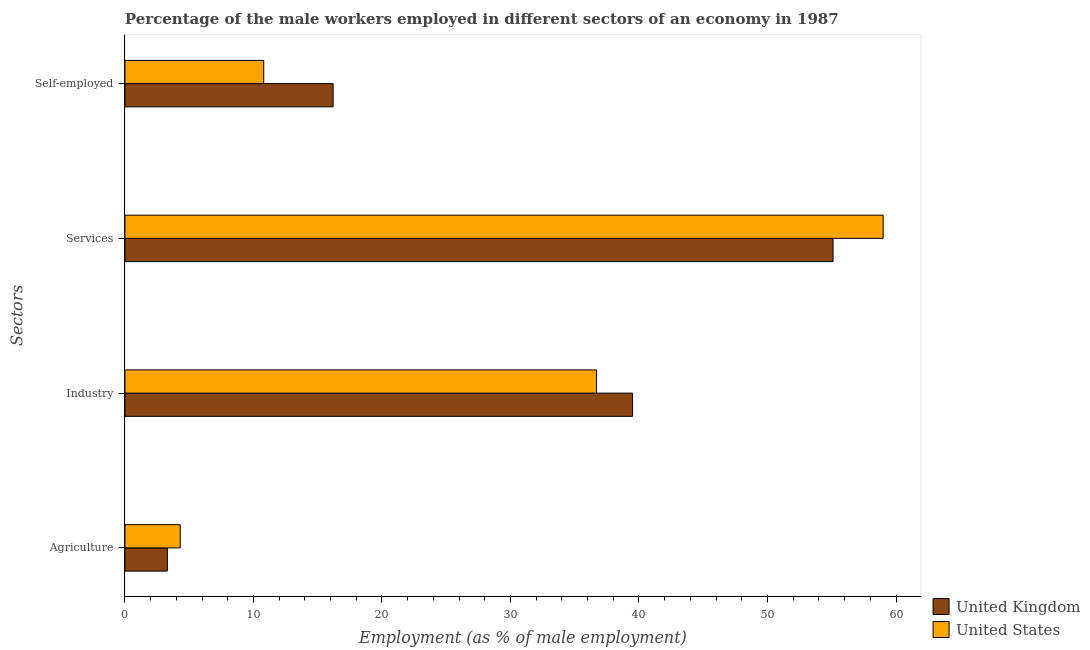Are the number of bars per tick equal to the number of legend labels?
Provide a succinct answer. Yes. What is the label of the 1st group of bars from the top?
Keep it short and to the point. Self-employed. What is the percentage of self employed male workers in United States?
Your response must be concise. 10.8. Across all countries, what is the maximum percentage of male workers in agriculture?
Offer a terse response. 4.3. Across all countries, what is the minimum percentage of male workers in industry?
Provide a short and direct response. 36.7. In which country was the percentage of self employed male workers minimum?
Keep it short and to the point. United States. What is the total percentage of male workers in agriculture in the graph?
Offer a very short reply. 7.6. What is the difference between the percentage of male workers in industry in United States and that in United Kingdom?
Make the answer very short. -2.8. What is the difference between the percentage of self employed male workers in United Kingdom and the percentage of male workers in services in United States?
Offer a very short reply. -42.8. What is the average percentage of male workers in services per country?
Provide a succinct answer. 57.05. What is the difference between the percentage of male workers in industry and percentage of self employed male workers in United Kingdom?
Offer a very short reply. 23.3. In how many countries, is the percentage of male workers in industry greater than 14 %?
Your response must be concise. 2. What is the ratio of the percentage of male workers in services in United Kingdom to that in United States?
Keep it short and to the point. 0.93. Is the percentage of self employed male workers in United Kingdom less than that in United States?
Your answer should be compact. No. Is the difference between the percentage of male workers in industry in United Kingdom and United States greater than the difference between the percentage of male workers in agriculture in United Kingdom and United States?
Provide a short and direct response. Yes. What is the difference between the highest and the second highest percentage of male workers in services?
Ensure brevity in your answer.  3.9. What is the difference between the highest and the lowest percentage of male workers in services?
Provide a succinct answer. 3.9. In how many countries, is the percentage of male workers in services greater than the average percentage of male workers in services taken over all countries?
Make the answer very short. 1. What does the 2nd bar from the top in Services represents?
Your response must be concise. United Kingdom. Is it the case that in every country, the sum of the percentage of male workers in agriculture and percentage of male workers in industry is greater than the percentage of male workers in services?
Your answer should be compact. No. How many bars are there?
Your response must be concise. 8. Are all the bars in the graph horizontal?
Your answer should be very brief. Yes. Where does the legend appear in the graph?
Offer a very short reply. Bottom right. How many legend labels are there?
Your response must be concise. 2. How are the legend labels stacked?
Provide a succinct answer. Vertical. What is the title of the graph?
Your response must be concise. Percentage of the male workers employed in different sectors of an economy in 1987. What is the label or title of the X-axis?
Give a very brief answer. Employment (as % of male employment). What is the label or title of the Y-axis?
Your answer should be very brief. Sectors. What is the Employment (as % of male employment) of United Kingdom in Agriculture?
Provide a short and direct response. 3.3. What is the Employment (as % of male employment) of United States in Agriculture?
Provide a succinct answer. 4.3. What is the Employment (as % of male employment) in United Kingdom in Industry?
Provide a short and direct response. 39.5. What is the Employment (as % of male employment) of United States in Industry?
Provide a succinct answer. 36.7. What is the Employment (as % of male employment) in United Kingdom in Services?
Provide a succinct answer. 55.1. What is the Employment (as % of male employment) in United States in Services?
Provide a short and direct response. 59. What is the Employment (as % of male employment) in United Kingdom in Self-employed?
Provide a succinct answer. 16.2. What is the Employment (as % of male employment) in United States in Self-employed?
Your response must be concise. 10.8. Across all Sectors, what is the maximum Employment (as % of male employment) of United Kingdom?
Your answer should be compact. 55.1. Across all Sectors, what is the minimum Employment (as % of male employment) of United Kingdom?
Keep it short and to the point. 3.3. Across all Sectors, what is the minimum Employment (as % of male employment) in United States?
Keep it short and to the point. 4.3. What is the total Employment (as % of male employment) in United Kingdom in the graph?
Provide a succinct answer. 114.1. What is the total Employment (as % of male employment) in United States in the graph?
Give a very brief answer. 110.8. What is the difference between the Employment (as % of male employment) of United Kingdom in Agriculture and that in Industry?
Provide a succinct answer. -36.2. What is the difference between the Employment (as % of male employment) in United States in Agriculture and that in Industry?
Your response must be concise. -32.4. What is the difference between the Employment (as % of male employment) in United Kingdom in Agriculture and that in Services?
Provide a short and direct response. -51.8. What is the difference between the Employment (as % of male employment) in United States in Agriculture and that in Services?
Give a very brief answer. -54.7. What is the difference between the Employment (as % of male employment) in United Kingdom in Industry and that in Services?
Provide a short and direct response. -15.6. What is the difference between the Employment (as % of male employment) in United States in Industry and that in Services?
Your response must be concise. -22.3. What is the difference between the Employment (as % of male employment) in United Kingdom in Industry and that in Self-employed?
Make the answer very short. 23.3. What is the difference between the Employment (as % of male employment) in United States in Industry and that in Self-employed?
Offer a terse response. 25.9. What is the difference between the Employment (as % of male employment) in United Kingdom in Services and that in Self-employed?
Your answer should be very brief. 38.9. What is the difference between the Employment (as % of male employment) in United States in Services and that in Self-employed?
Your response must be concise. 48.2. What is the difference between the Employment (as % of male employment) of United Kingdom in Agriculture and the Employment (as % of male employment) of United States in Industry?
Keep it short and to the point. -33.4. What is the difference between the Employment (as % of male employment) in United Kingdom in Agriculture and the Employment (as % of male employment) in United States in Services?
Your response must be concise. -55.7. What is the difference between the Employment (as % of male employment) in United Kingdom in Agriculture and the Employment (as % of male employment) in United States in Self-employed?
Provide a succinct answer. -7.5. What is the difference between the Employment (as % of male employment) in United Kingdom in Industry and the Employment (as % of male employment) in United States in Services?
Ensure brevity in your answer.  -19.5. What is the difference between the Employment (as % of male employment) in United Kingdom in Industry and the Employment (as % of male employment) in United States in Self-employed?
Your answer should be compact. 28.7. What is the difference between the Employment (as % of male employment) of United Kingdom in Services and the Employment (as % of male employment) of United States in Self-employed?
Give a very brief answer. 44.3. What is the average Employment (as % of male employment) of United Kingdom per Sectors?
Keep it short and to the point. 28.52. What is the average Employment (as % of male employment) in United States per Sectors?
Offer a very short reply. 27.7. What is the ratio of the Employment (as % of male employment) in United Kingdom in Agriculture to that in Industry?
Your answer should be compact. 0.08. What is the ratio of the Employment (as % of male employment) in United States in Agriculture to that in Industry?
Your response must be concise. 0.12. What is the ratio of the Employment (as % of male employment) in United Kingdom in Agriculture to that in Services?
Provide a short and direct response. 0.06. What is the ratio of the Employment (as % of male employment) in United States in Agriculture to that in Services?
Provide a short and direct response. 0.07. What is the ratio of the Employment (as % of male employment) in United Kingdom in Agriculture to that in Self-employed?
Provide a short and direct response. 0.2. What is the ratio of the Employment (as % of male employment) of United States in Agriculture to that in Self-employed?
Offer a very short reply. 0.4. What is the ratio of the Employment (as % of male employment) of United Kingdom in Industry to that in Services?
Offer a very short reply. 0.72. What is the ratio of the Employment (as % of male employment) in United States in Industry to that in Services?
Your answer should be very brief. 0.62. What is the ratio of the Employment (as % of male employment) of United Kingdom in Industry to that in Self-employed?
Your answer should be compact. 2.44. What is the ratio of the Employment (as % of male employment) of United States in Industry to that in Self-employed?
Provide a short and direct response. 3.4. What is the ratio of the Employment (as % of male employment) of United Kingdom in Services to that in Self-employed?
Give a very brief answer. 3.4. What is the ratio of the Employment (as % of male employment) in United States in Services to that in Self-employed?
Ensure brevity in your answer.  5.46. What is the difference between the highest and the second highest Employment (as % of male employment) in United Kingdom?
Give a very brief answer. 15.6. What is the difference between the highest and the second highest Employment (as % of male employment) in United States?
Your answer should be very brief. 22.3. What is the difference between the highest and the lowest Employment (as % of male employment) of United Kingdom?
Keep it short and to the point. 51.8. What is the difference between the highest and the lowest Employment (as % of male employment) in United States?
Your answer should be very brief. 54.7. 